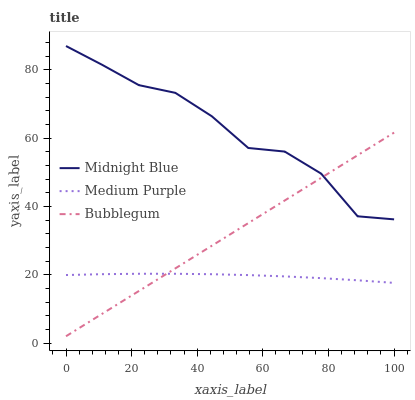Does Bubblegum have the minimum area under the curve?
Answer yes or no. No. Does Bubblegum have the maximum area under the curve?
Answer yes or no. No. Is Midnight Blue the smoothest?
Answer yes or no. No. Is Bubblegum the roughest?
Answer yes or no. No. Does Midnight Blue have the lowest value?
Answer yes or no. No. Does Bubblegum have the highest value?
Answer yes or no. No. Is Medium Purple less than Midnight Blue?
Answer yes or no. Yes. Is Midnight Blue greater than Medium Purple?
Answer yes or no. Yes. Does Medium Purple intersect Midnight Blue?
Answer yes or no. No. 